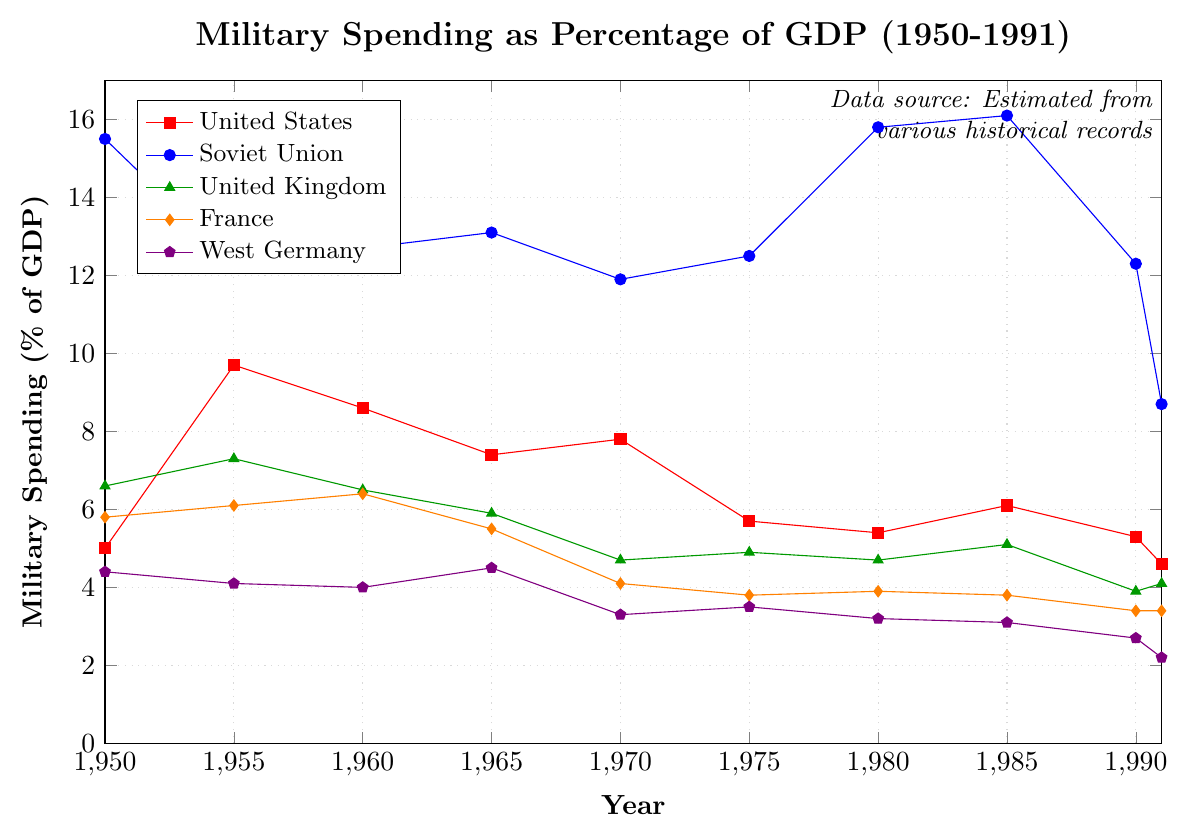What year did the United States have its highest military spending as a percentage of GDP, and what was that percentage? The data shows the highest value for the United States military spending percentage in 1955 at 9.7%.
Answer: 1955, 9.7% How did the military spending of the Soviet Union change between 1980 and 1991? In 1980, the Soviet Union's military spending was 15.8% of GDP. By 1991, it had decreased to 8.7%. The difference is 15.8% - 8.7% = 7.1%.
Answer: It decreased by 7.1% Which country had the lowest military spending as a percentage of GDP in 1991? In 1991, the percentages were as follows: United States (4.6%), Soviet Union (8.7%), United Kingdom (4.1%), France (3.4%), West Germany (2.2%). West Germany has the lowest percentage.
Answer: West Germany What is the average military spending as a percentage of GDP for France from 1950 to 1991? The values for France are 5.8%, 6.1%, 6.4%, 5.5%, 4.1%, 3.8%, 3.9%, 3.8%, 3.4%, and 3.4%. Adding these values and dividing by 10 gives (5.8 + 6.1 + 6.4 + 5.5 + 4.1 + 3.8 + 3.9 + 3.8 + 3.4 + 3.4) / 10 = 4.82%.
Answer: 4.82% Between which two consecutive years did the military spending of West Germany see the largest decrease as a percentage of GDP? The differences between consecutive years are: 1950-1955 (-0.3), 1955-1960 (-0.1), 1960-1965 (+0.5), 1965-1970 (-1.2), 1970-1975 (+0.2), 1975-1980 (-0.3), 1980-1985 (-0.1), 1985-1990 (-0.4), 1990-1991 (-0.5). The largest decrease is between 1965 and 1970, which is -1.2%.
Answer: 1965-1970 Compare the military spending as a percentage of GDP of the United Kingdom and France in 1960. Which was higher and by how much? In 1960, the United Kingdom's military spending was 6.5% and France's was 6.4%. The difference is 6.5% - 6.4% = 0.1%.
Answer: United Kingdom by 0.1% What was the trend of military spending as a percentage of GDP for the United States from 1950 to 1991? The United States' military spending started at 5.0% in 1950, peaked at 9.7% in 1955, then generally decreased with some fluctuations, reaching 4.6% in 1991. The overall trend is a decrease.
Answer: Decreasing What was the mid-value (median) of military spending as a percentage of GDP for the Soviet Union over the given years? The Soviet Union's percentages are 15.5, 12.3, 12.7, 13.1, 11.9, 12.5, 15.8, 16.1, 12.3, and 8.7. Arranging them in ascending order: 8.7, 11.9, 12.3, 12.3, 12.5, 12.7, 13.1, 15.5, 15.8, 16.1. The median is (12.5 + 12.7) / 2 = 12.6%.
Answer: 12.6% How did France's military spending percentage compare to that of the average (mean) military spending percentage of West Germany over the years? The mean military spending percentage of West Germany is the sum of its percentages divided by the number of data points: (4.4 + 4.1 + 4.0 + 4.5 + 3.3 + 3.5 + 3.2 + 3.1 + 2.7 + 2.2) / 10 = 3.5%. Comparing this to the average percentage of France, which is 4.82%, France's spending is higher.
Answer: France higher Which country saw the least change in its military spending as a percentage of GDP from 1950 to 1991? The change in percentage points from 1950 to 1991 for each country is as follows: United States (4.6 - 5.0 = -0.4), Soviet Union (8.7 - 15.5 = -6.8), United Kingdom (4.1 - 6.6 = -2.5), France (3.4 - 5.8 = -2.4), and West Germany (2.2 - 4.4 = -2.2). West Germany saw the least change.
Answer: West Germany 